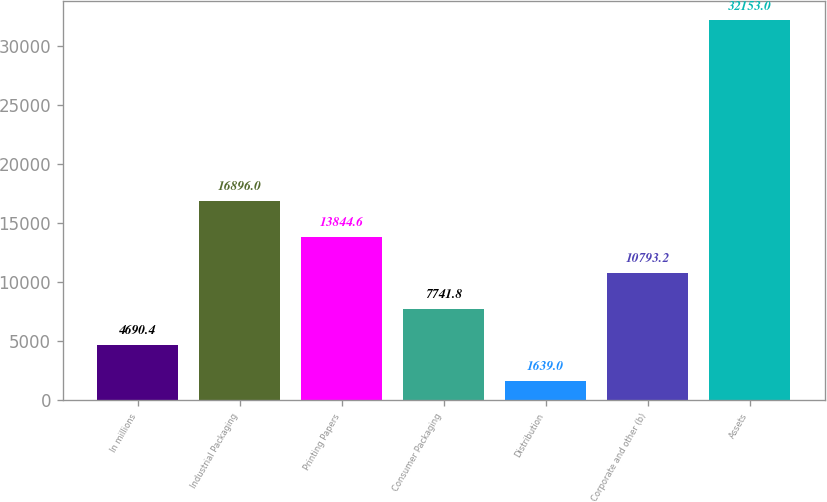Convert chart. <chart><loc_0><loc_0><loc_500><loc_500><bar_chart><fcel>In millions<fcel>Industrial Packaging<fcel>Printing Papers<fcel>Consumer Packaging<fcel>Distribution<fcel>Corporate and other (b)<fcel>Assets<nl><fcel>4690.4<fcel>16896<fcel>13844.6<fcel>7741.8<fcel>1639<fcel>10793.2<fcel>32153<nl></chart> 